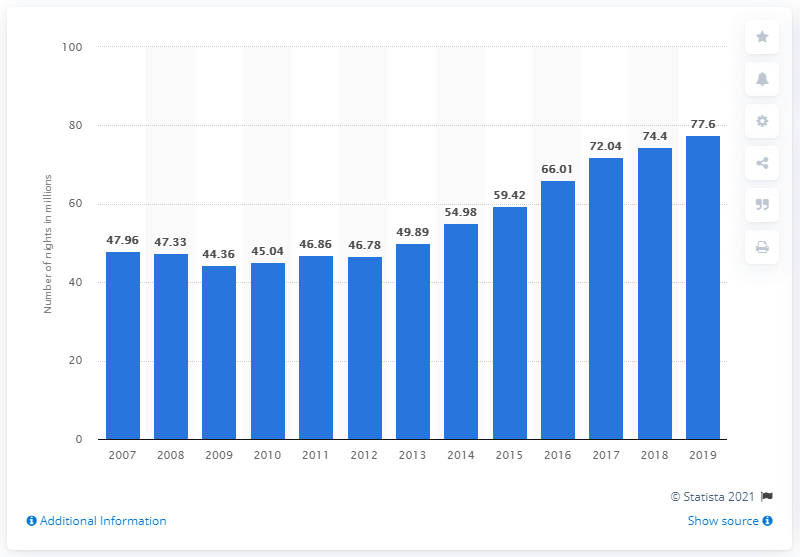List a handful of essential elements in this visual. From 2007 to 2019, an estimated 77.6 nights were spent at tourist accommodation establishments in Portugal. 